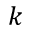<formula> <loc_0><loc_0><loc_500><loc_500>k</formula> 